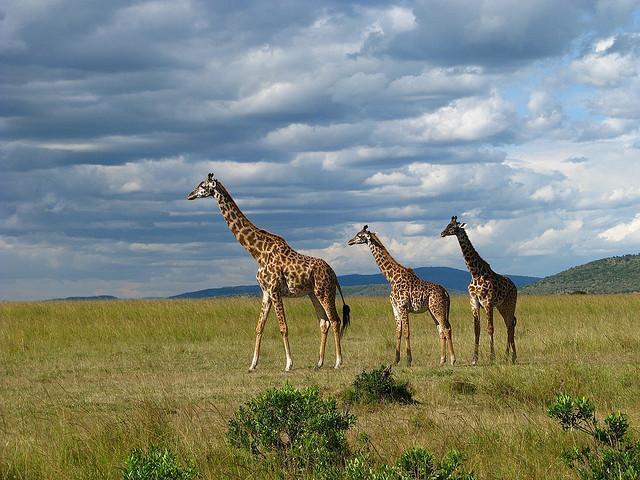How many giraffes are there?
Give a very brief answer. 3. 